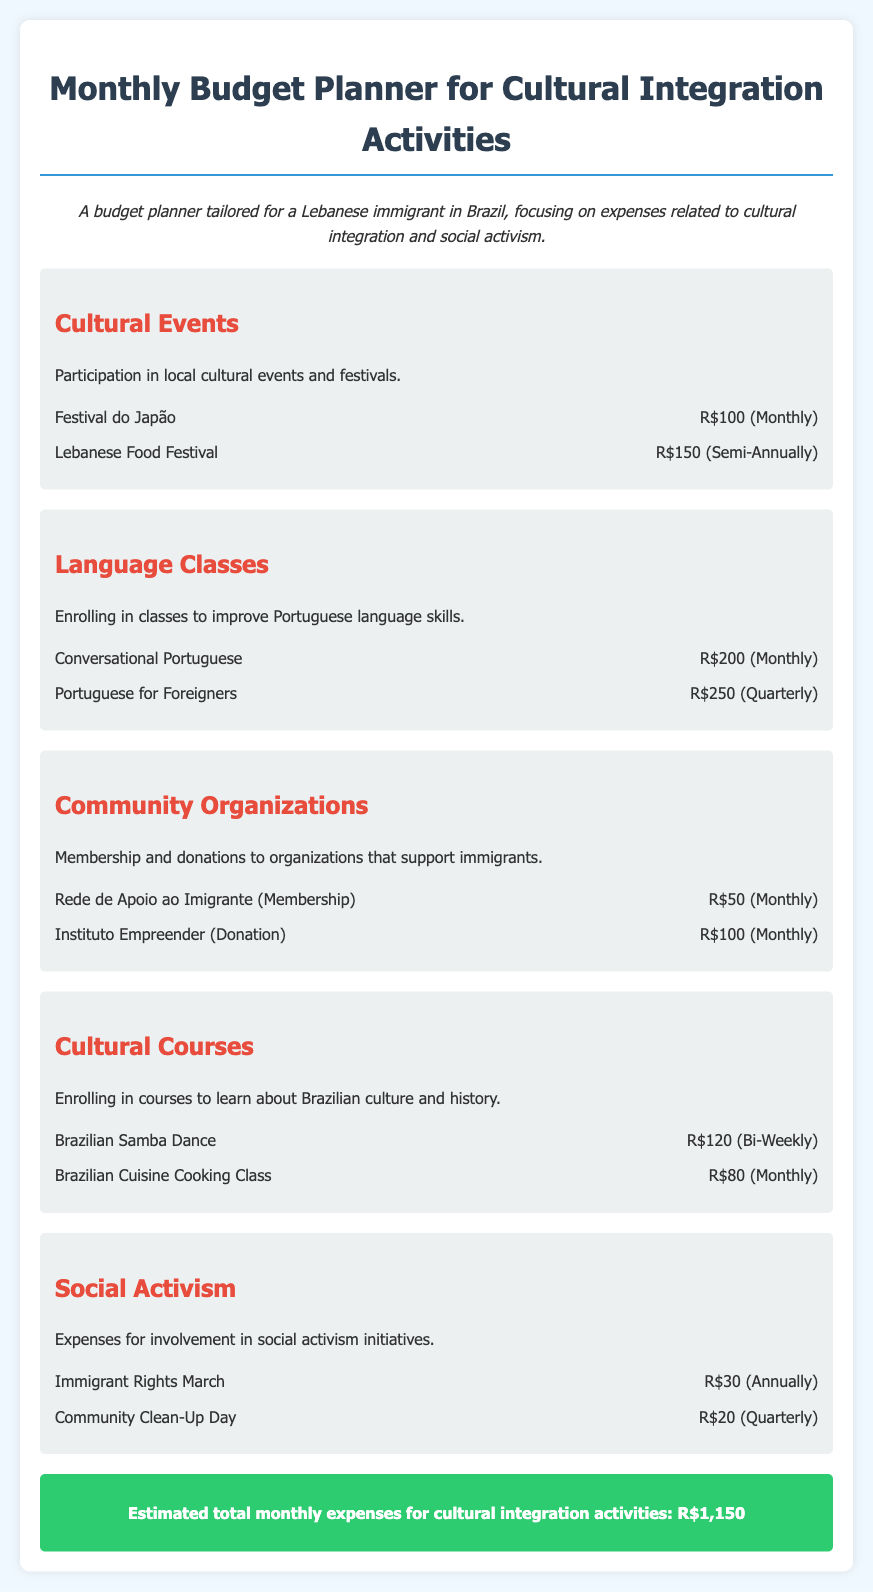What is the total monthly expense for cultural integration activities? The total monthly expense is calculated by summing up all monthly expenses listed in the document.
Answer: R$1,150 How much does the Conversational Portuguese class cost? The cost of the Conversational Portuguese class is specified in the language classes section of the document.
Answer: R$200 What type of class is offered bi-weekly? The class that is offered bi-weekly is mentioned in the cultural courses section, which involves learning a specific skill.
Answer: Brazilian Samba Dance How much is the donation to Instituto Empreender? The document lists the donation amount for Instituto Empreender under community organizations.
Answer: R$100 What is the frequency for the Lebanese Food Festival expense? The frequency indicates how often the expense occurs, as stated in the cultural events section.
Answer: Semi-Annually What organization requires a monthly membership fee? The membership organization requiring a monthly fee is listed under community organizations in the document.
Answer: Rede de Apoio ao Imigrante How often is the Immigrant Rights March expense incurred? The frequency of the Immigrant Rights March expense is specified in the social activism section of the document.
Answer: Annually What is the cost of attending the Brazilian Cuisine Cooking Class? The cost of the Brazilian Cuisine Cooking Class is provided in the cultural courses section of the document.
Answer: R$80 What type of activities does this budget planner focus on? The type of activities emphasized in the budget planner is indicated in the introductory statement of the document.
Answer: Cultural integration and social activism 